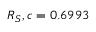<formula> <loc_0><loc_0><loc_500><loc_500>R _ { S } , c = 0 . 6 9 9 3</formula> 